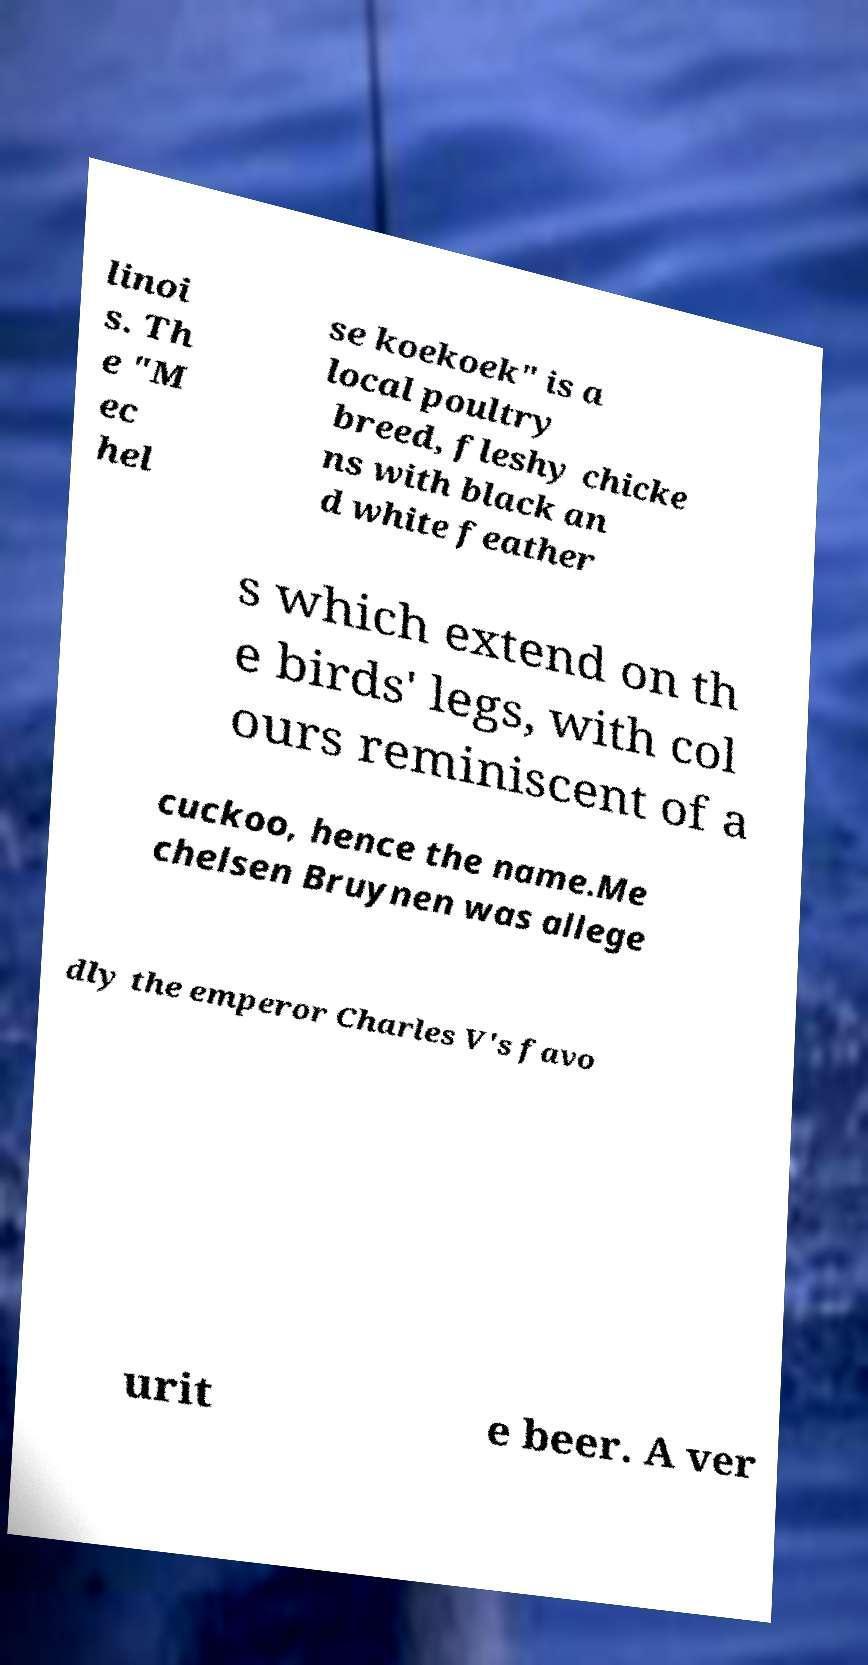Please identify and transcribe the text found in this image. linoi s. Th e "M ec hel se koekoek" is a local poultry breed, fleshy chicke ns with black an d white feather s which extend on th e birds' legs, with col ours reminiscent of a cuckoo, hence the name.Me chelsen Bruynen was allege dly the emperor Charles V's favo urit e beer. A ver 